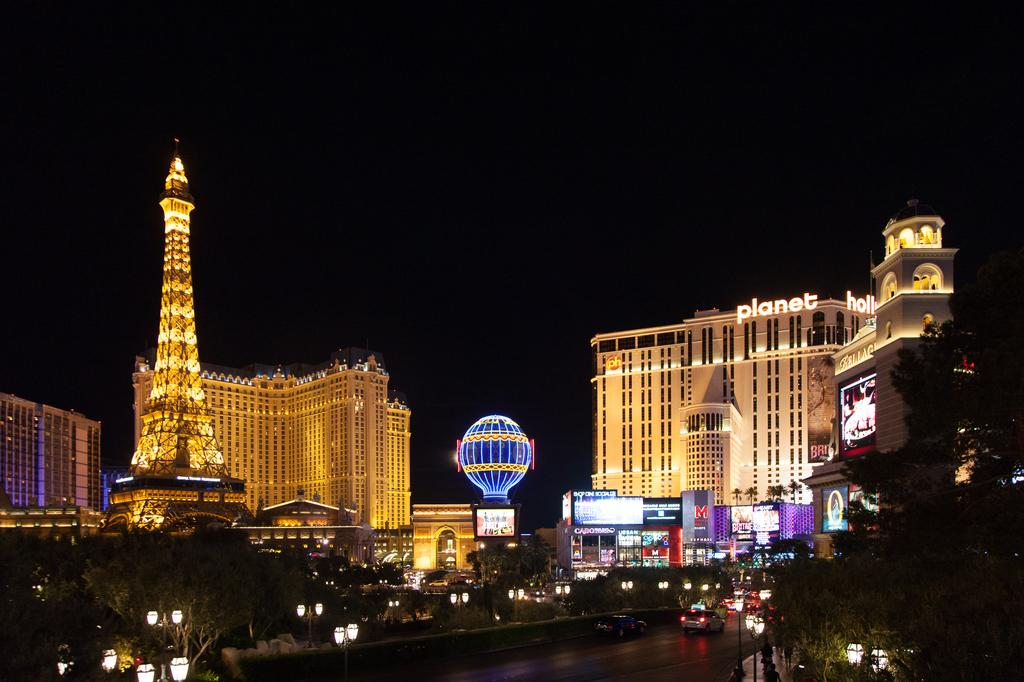What can be seen on the road in the image? There are vehicles on the road in the image. What structures are present along the road? There are light poles in the image. What type of vegetation is visible in the image? There are trees in the image. What is located on the left side of the image? There is a Paris hotel on the left side of the image. What can be seen in the background of the image? There are buildings in the background of the image. What time of day is depicted in the image? It is night time in the image. What is the condition of the sky in the image? The sky is clear in the image. Can you see any cactus plants in the image? There are no cactus plants present in the image. What type of beast is roaming around in the image? There are no beasts present in the image. 